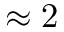Convert formula to latex. <formula><loc_0><loc_0><loc_500><loc_500>\approx 2</formula> 